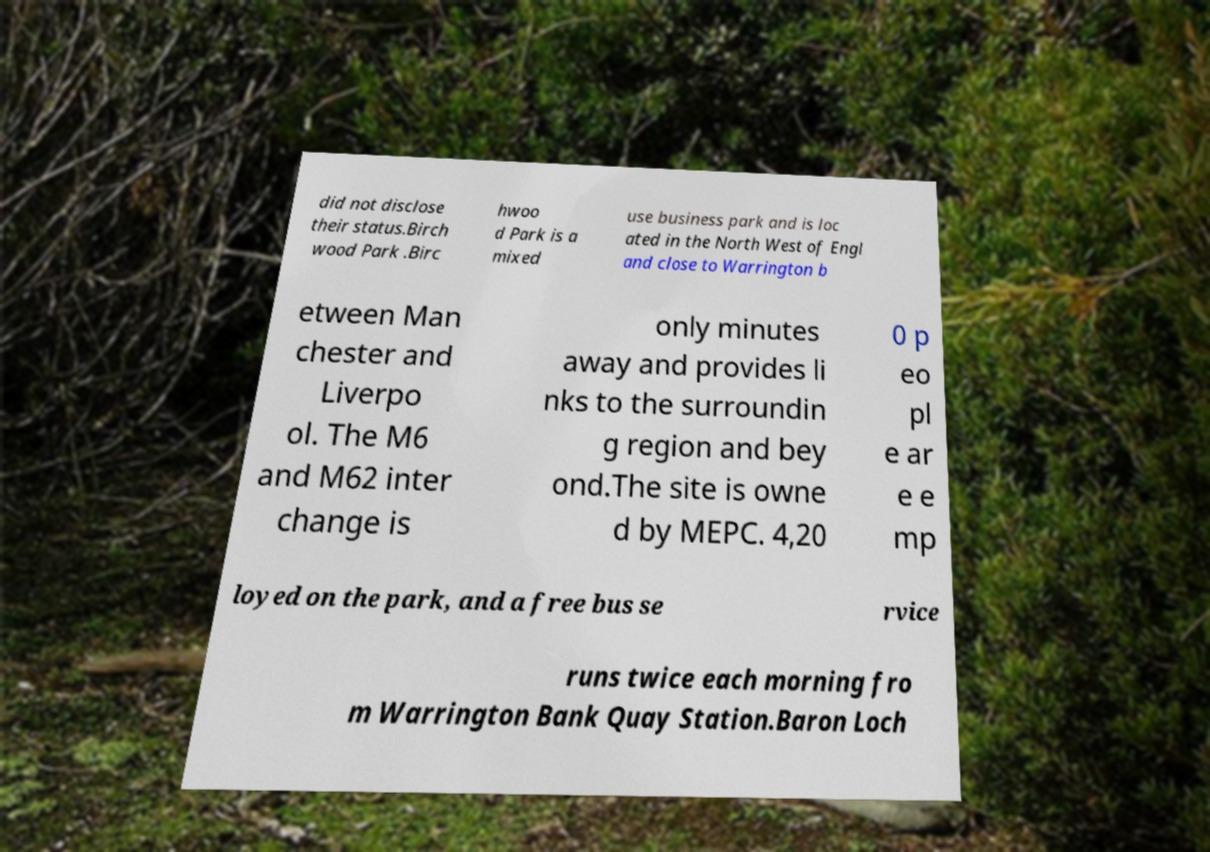Please read and relay the text visible in this image. What does it say? did not disclose their status.Birch wood Park .Birc hwoo d Park is a mixed use business park and is loc ated in the North West of Engl and close to Warrington b etween Man chester and Liverpo ol. The M6 and M62 inter change is only minutes away and provides li nks to the surroundin g region and bey ond.The site is owne d by MEPC. 4,20 0 p eo pl e ar e e mp loyed on the park, and a free bus se rvice runs twice each morning fro m Warrington Bank Quay Station.Baron Loch 